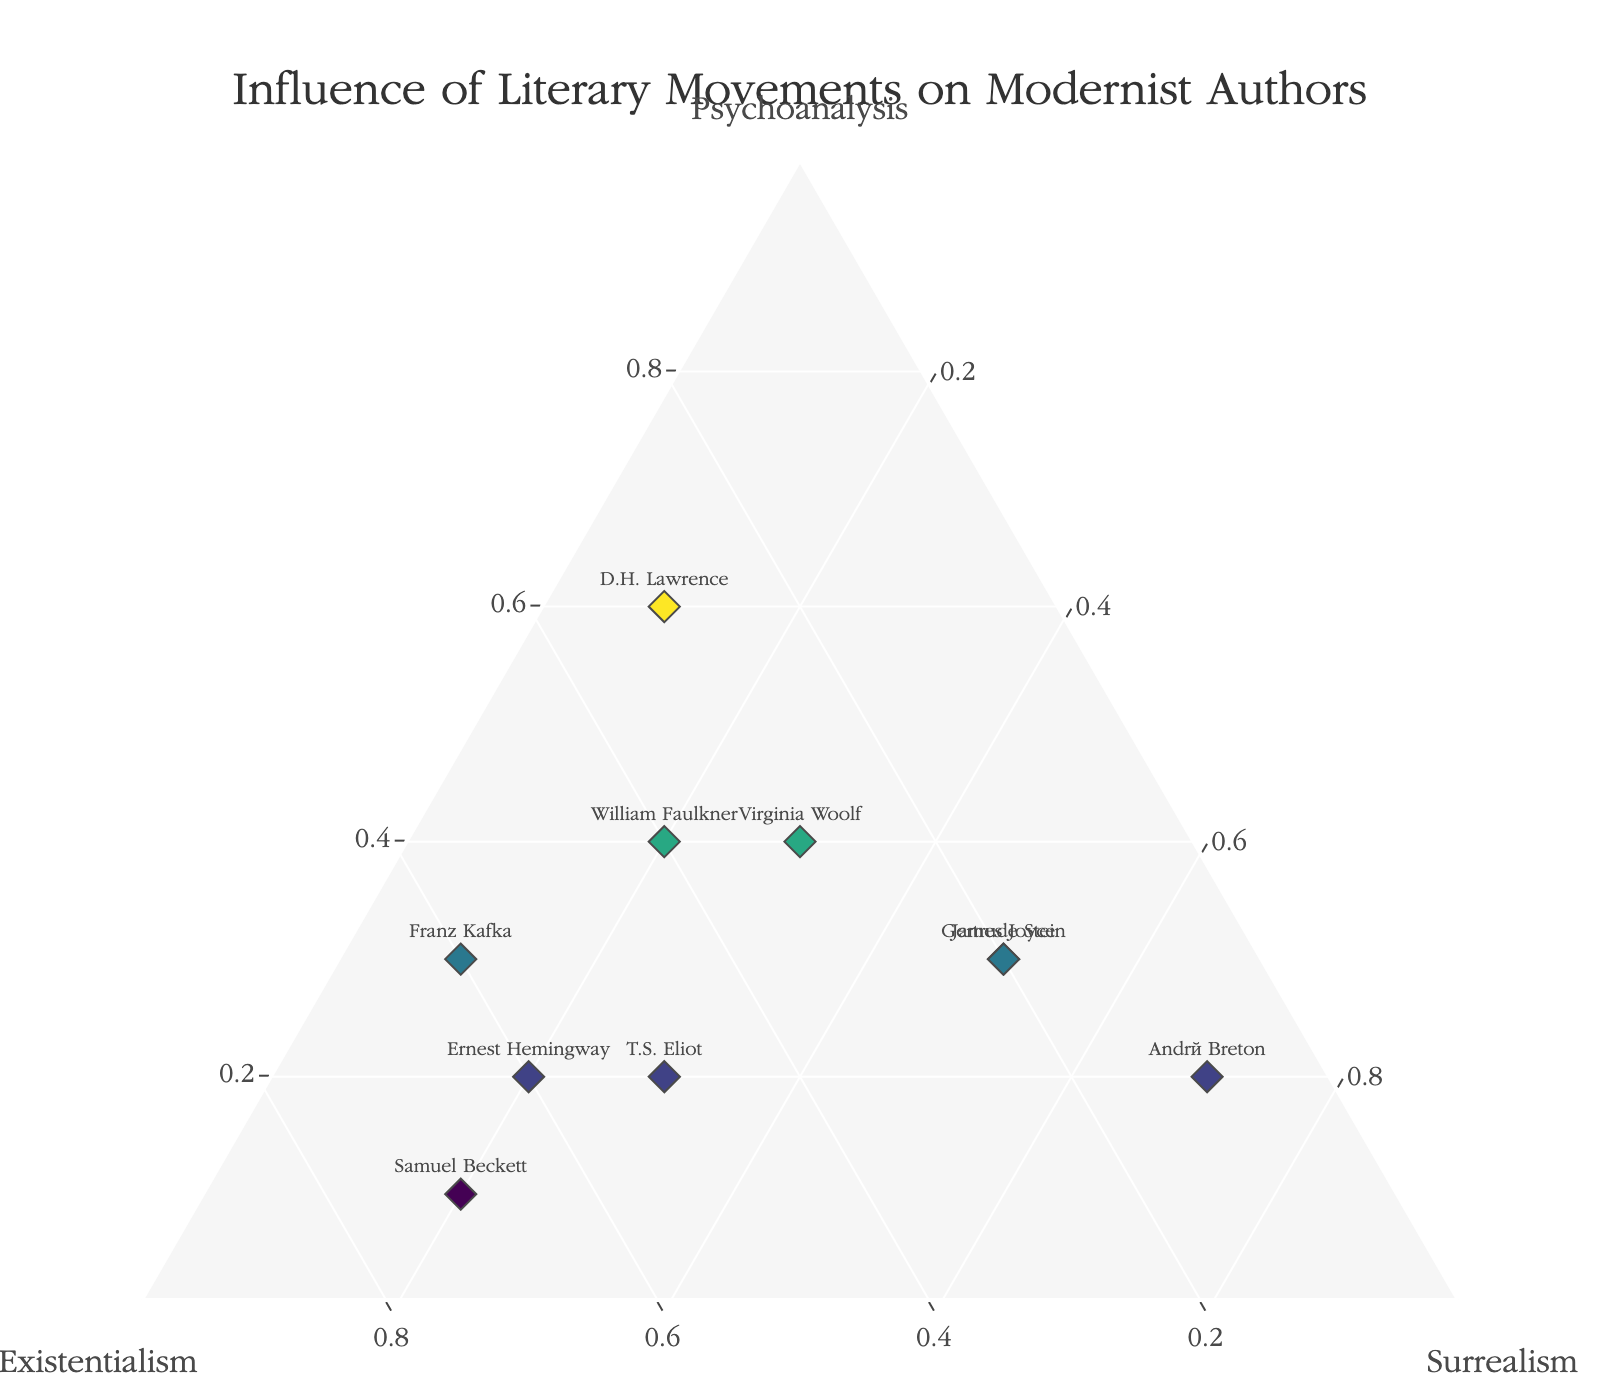What is the title of the plot? The title of the plot can be seen at the top of the graph.
Answer: Influence of Literary Movements on Modernist Authors Which axis represents the influence of Surrealism on modernist authors? The axis labeled "Surrealism" on the ternary plot represents this influence.
Answer: c-axis How many authors are depicted in this plot? Count the number of different text labels (author names) in the plot.
Answer: 10 Which author has an equal influence of Psychoanalysis and Surrealism? Look for the author whose Psychoanalysis and Surrealism values are equal.
Answer: Virginia Woolf Which author has the highest influence from Existentialism? Identify the author located closest to the Existentialism axis (b-axis).
Answer: Samuel Beckett Compare the influence of Psychoanalysis between James Joyce and D.H. Lawrence. Who has a greater influence? Observe the positions of James Joyce and D.H. Lawrence with respect to the Psychoanalysis axis (a-axis). D.H. Lawrence is closer to the Psychoanalysis apex.
Answer: D.H. Lawrence Among Virginia Woolf, T.S. Eliot, and Gertrude Stein, who has the highest influence of Surrealism? Compare the positions of Virginia Woolf, T.S. Eliot, and Gertrude Stein on the Surrealism axis (c-axis). Gertrude Stein is closest to the Surrealism apex.
Answer: Gertrude Stein What is the combined influence score of Existentialism and Surrealism for Ernest Hemingway? Sum the values for Existentialism (0.6) and Surrealism (0.2) for Ernest Hemingway.
Answer: 0.8 What is the most common literary influence among these authors? Identify the apex (Psychoanalysis, Existentialism, Surrealism) that has the most authors closest to it.
Answer: Existentialism Which author has the least influence from Psychoanalysis and what is their primary influence? Find the author closest to the base opposite the Psychoanalysis apex (Samuel Beckett) and identify their primary influence (Existentialism).
Answer: Samuel Beckett, Existentialism 